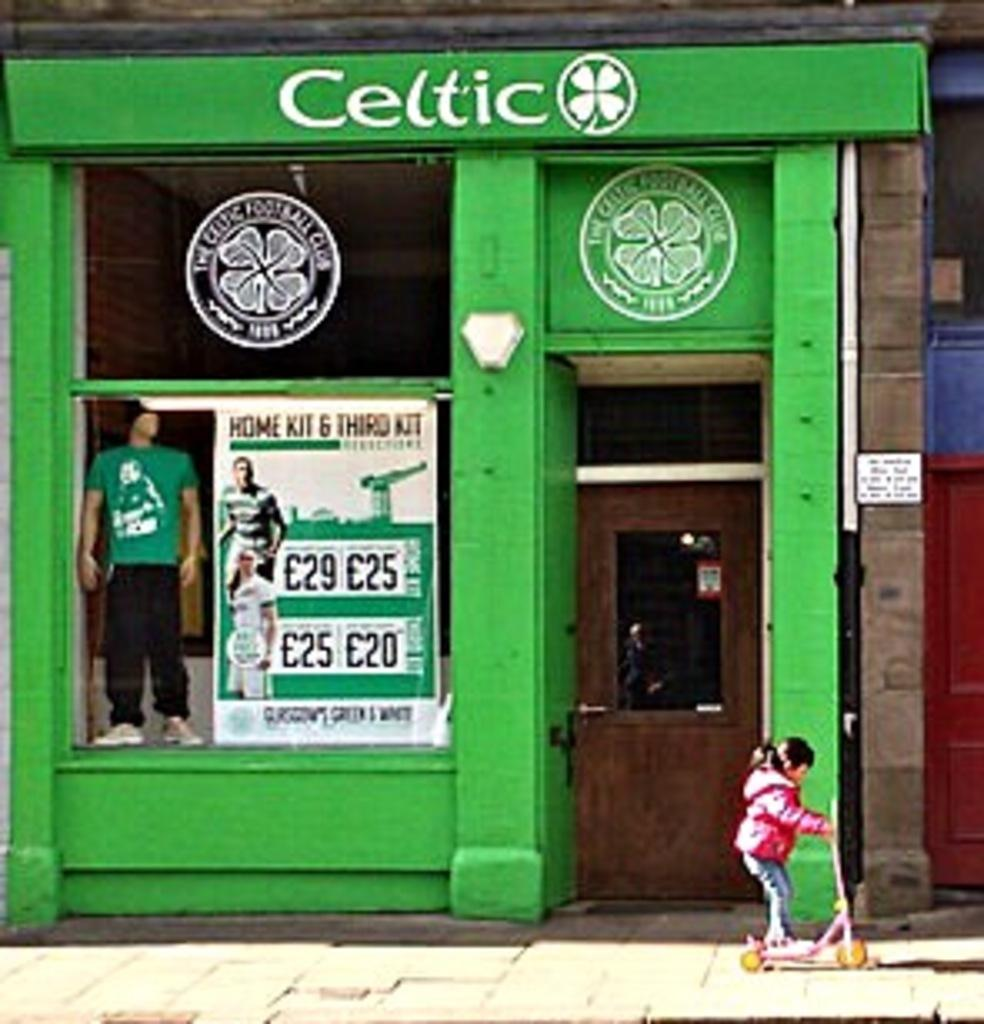<image>
Share a concise interpretation of the image provided. a celtic store that a girl is passing by 